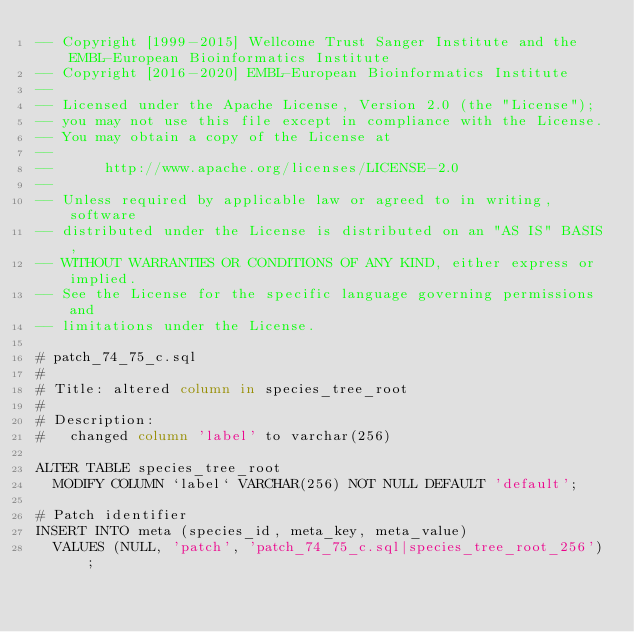Convert code to text. <code><loc_0><loc_0><loc_500><loc_500><_SQL_>-- Copyright [1999-2015] Wellcome Trust Sanger Institute and the EMBL-European Bioinformatics Institute
-- Copyright [2016-2020] EMBL-European Bioinformatics Institute
-- 
-- Licensed under the Apache License, Version 2.0 (the "License");
-- you may not use this file except in compliance with the License.
-- You may obtain a copy of the License at
-- 
--      http://www.apache.org/licenses/LICENSE-2.0
-- 
-- Unless required by applicable law or agreed to in writing, software
-- distributed under the License is distributed on an "AS IS" BASIS,
-- WITHOUT WARRANTIES OR CONDITIONS OF ANY KIND, either express or implied.
-- See the License for the specific language governing permissions and
-- limitations under the License.

# patch_74_75_c.sql
#
# Title: altered column in species_tree_root
#
# Description:
#   changed column 'label' to varchar(256)

ALTER TABLE species_tree_root
	MODIFY COLUMN `label` VARCHAR(256) NOT NULL DEFAULT 'default';

# Patch identifier
INSERT INTO meta (species_id, meta_key, meta_value)
  VALUES (NULL, 'patch', 'patch_74_75_c.sql|species_tree_root_256');
</code> 